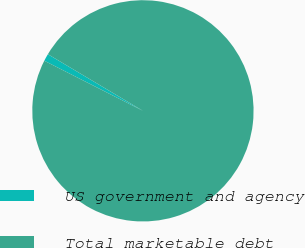<chart> <loc_0><loc_0><loc_500><loc_500><pie_chart><fcel>US government and agency<fcel>Total marketable debt<nl><fcel>1.07%<fcel>98.93%<nl></chart> 